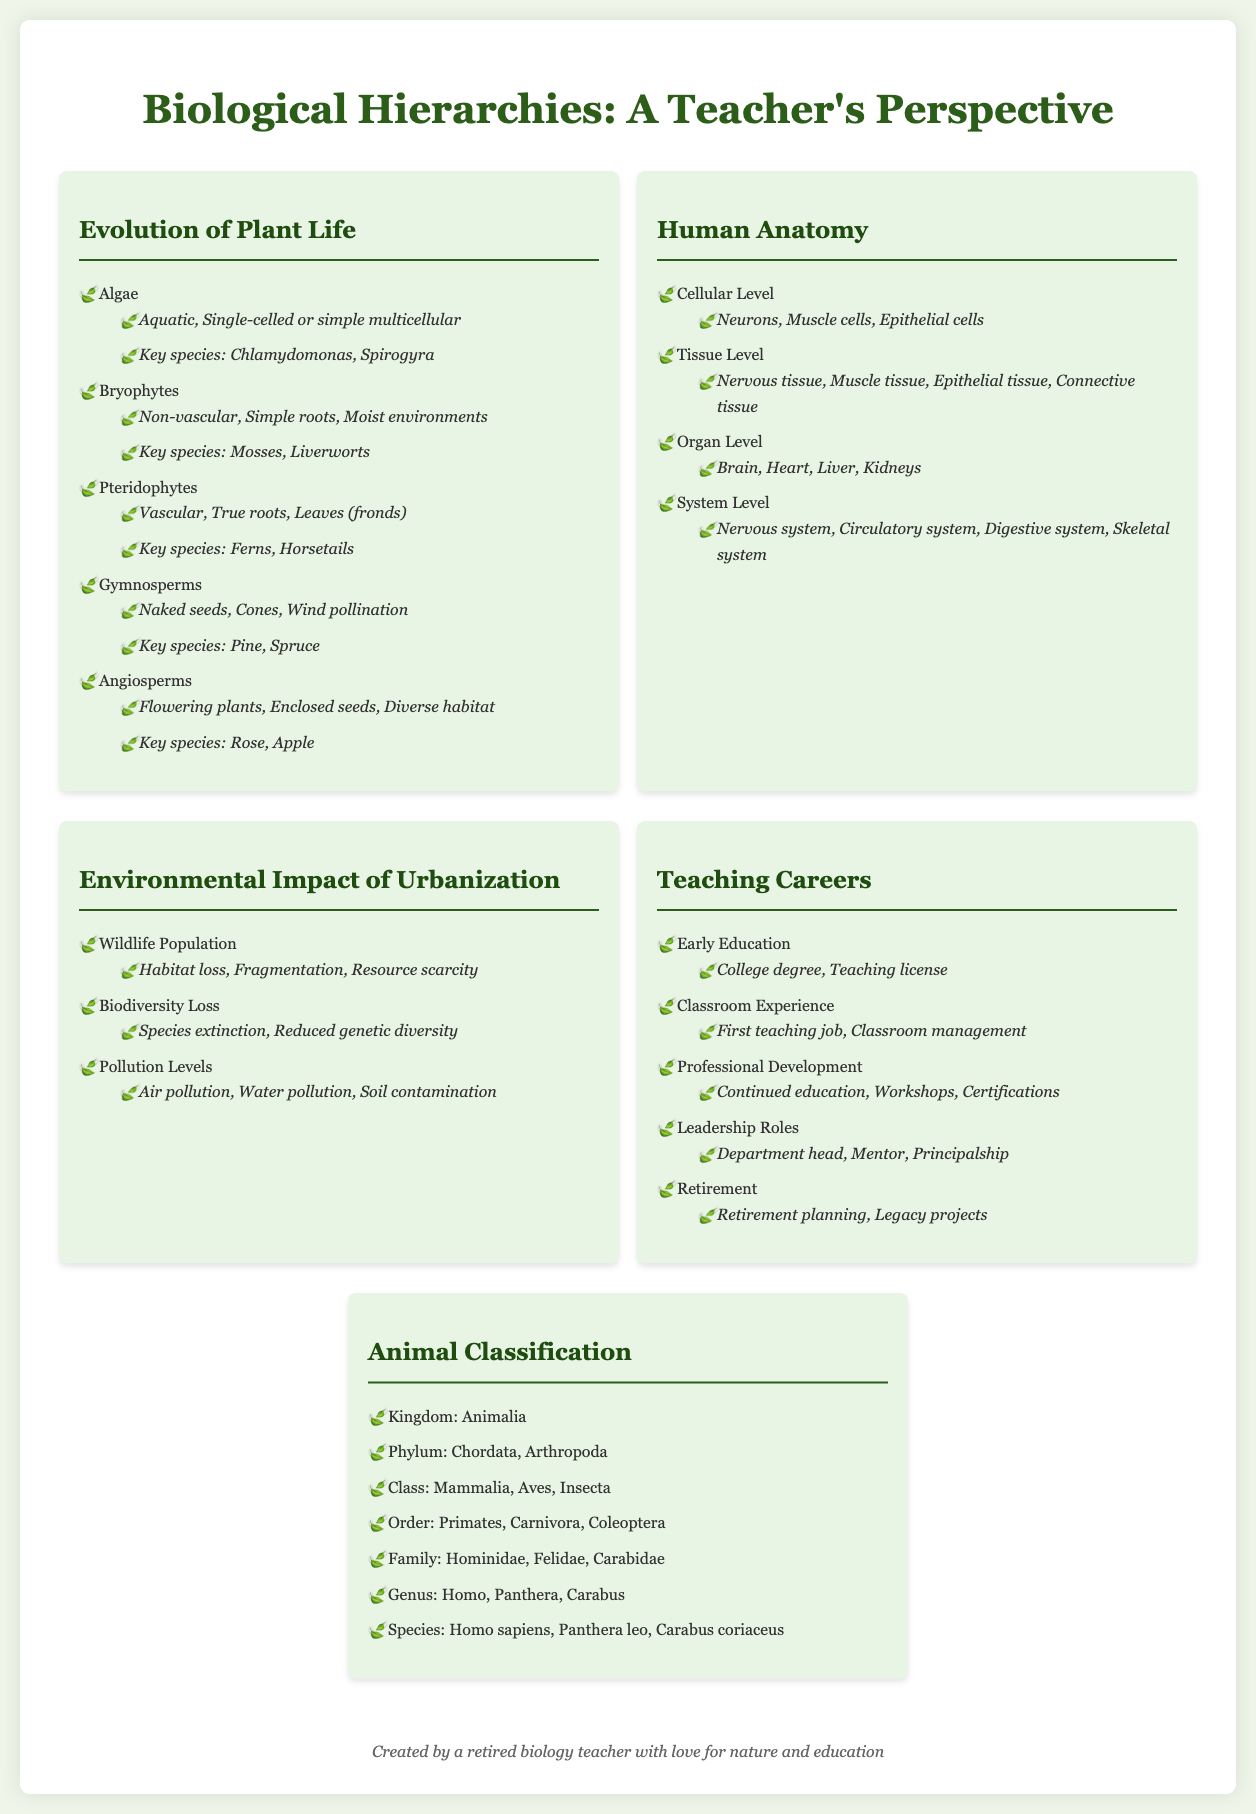What is the first group of plants in the evolution of plant life? The first group of plants listed in the document is algae, which is part of the evolution of plant life section.
Answer: Algae What are the key species of bryophytes mentioned? The document specifies mosses and liverworts as the key species of bryophytes.
Answer: Mosses, Liverworts Which cellular type is not included in the tissue level of human anatomy? The document lists nervous, muscle, epithelial, and connective tissues but does not include any specific cellular types. This question requires a comparison of cell types to tissue types.
Answer: None How many main levels are there in the hierarchy of human anatomy? The document outlines four main levels of human anatomy: cellular, tissue, organ, and system levels.
Answer: Four What is a major environmental impact of urbanization identified in the infographic? The document highlights wildlife population, biodiversity loss, and pollution levels as major impacts. This question focuses on summarizing a key point.
Answer: Wildlife Population What milestone comes after professional development in a teaching career? The document indicates that leadership roles follow professional development in the teaching careers hierarchy.
Answer: Leadership Roles How are gymnosperms primarily characterized in the evolution of plant life? The document characterizes gymnosperms through their method of reproduction, which is highlighting their naked seeds and cones.
Answer: Naked seeds What is the kingdom category in animal classification? The document identifies Animalia as the kingdom under animal classification.
Answer: Animalia Which organ is mentioned as part of the organ level in human anatomy? The document lists several organs, including the brain, heart, liver, and kidneys, as part of the organ level. This is a direct retrieval question.
Answer: Brain 